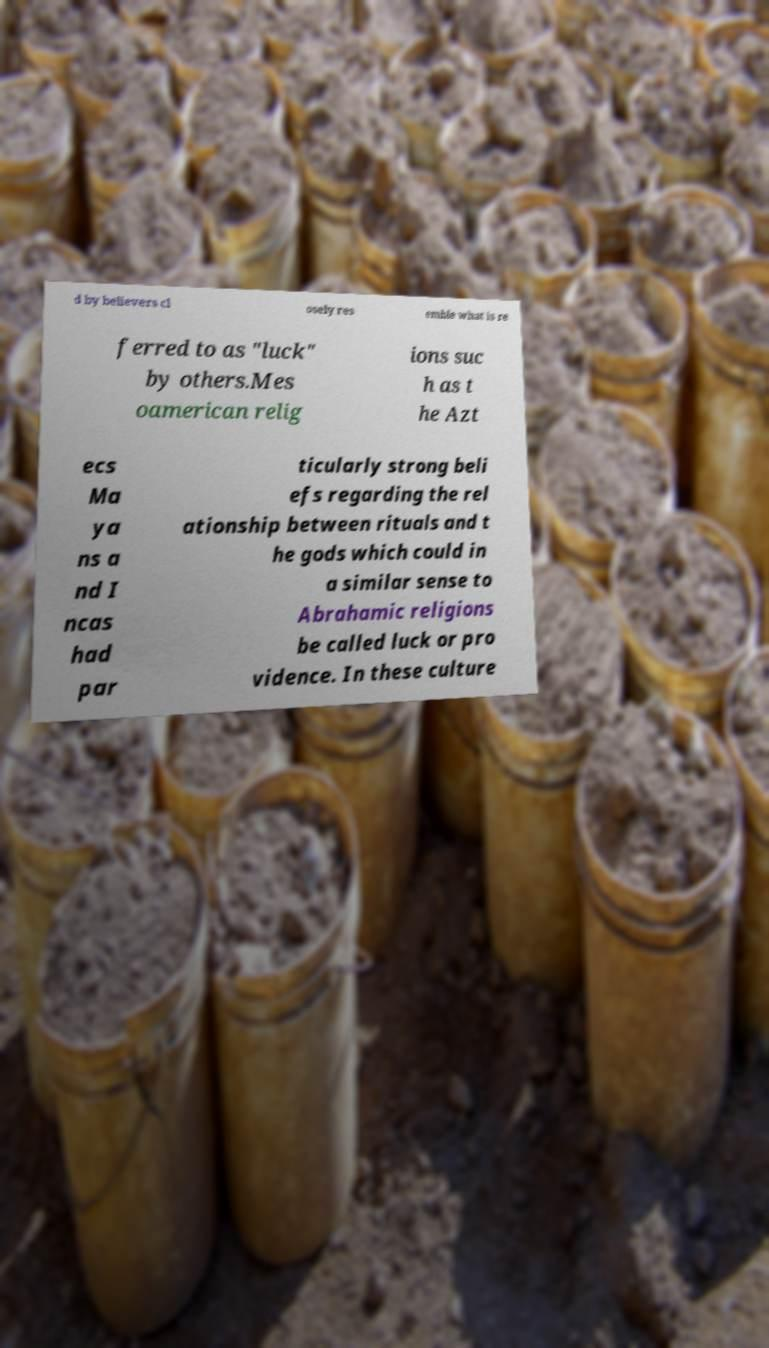Can you accurately transcribe the text from the provided image for me? d by believers cl osely res emble what is re ferred to as "luck" by others.Mes oamerican relig ions suc h as t he Azt ecs Ma ya ns a nd I ncas had par ticularly strong beli efs regarding the rel ationship between rituals and t he gods which could in a similar sense to Abrahamic religions be called luck or pro vidence. In these culture 